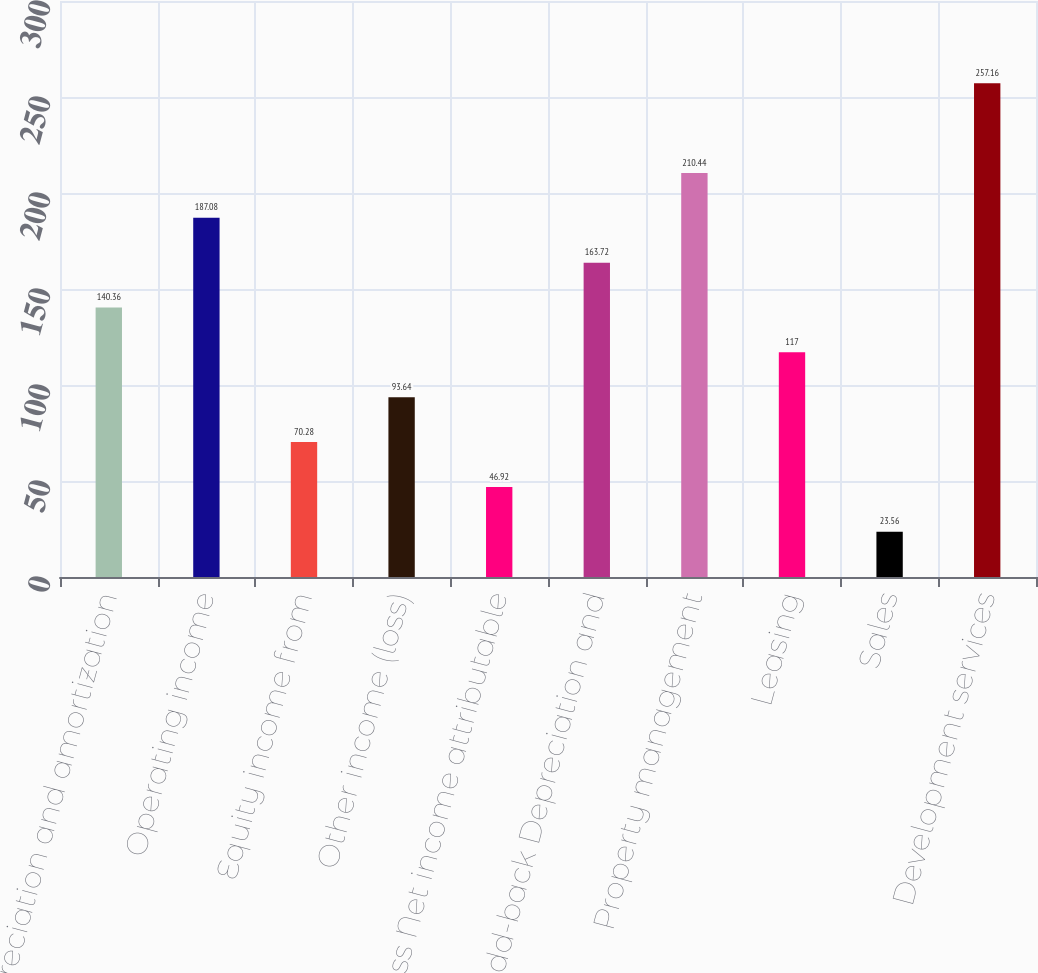Convert chart. <chart><loc_0><loc_0><loc_500><loc_500><bar_chart><fcel>Depreciation and amortization<fcel>Operating income<fcel>Equity income from<fcel>Other income (loss)<fcel>Less Net income attributable<fcel>Add-back Depreciation and<fcel>Property management<fcel>Leasing<fcel>Sales<fcel>Development services<nl><fcel>140.36<fcel>187.08<fcel>70.28<fcel>93.64<fcel>46.92<fcel>163.72<fcel>210.44<fcel>117<fcel>23.56<fcel>257.16<nl></chart> 